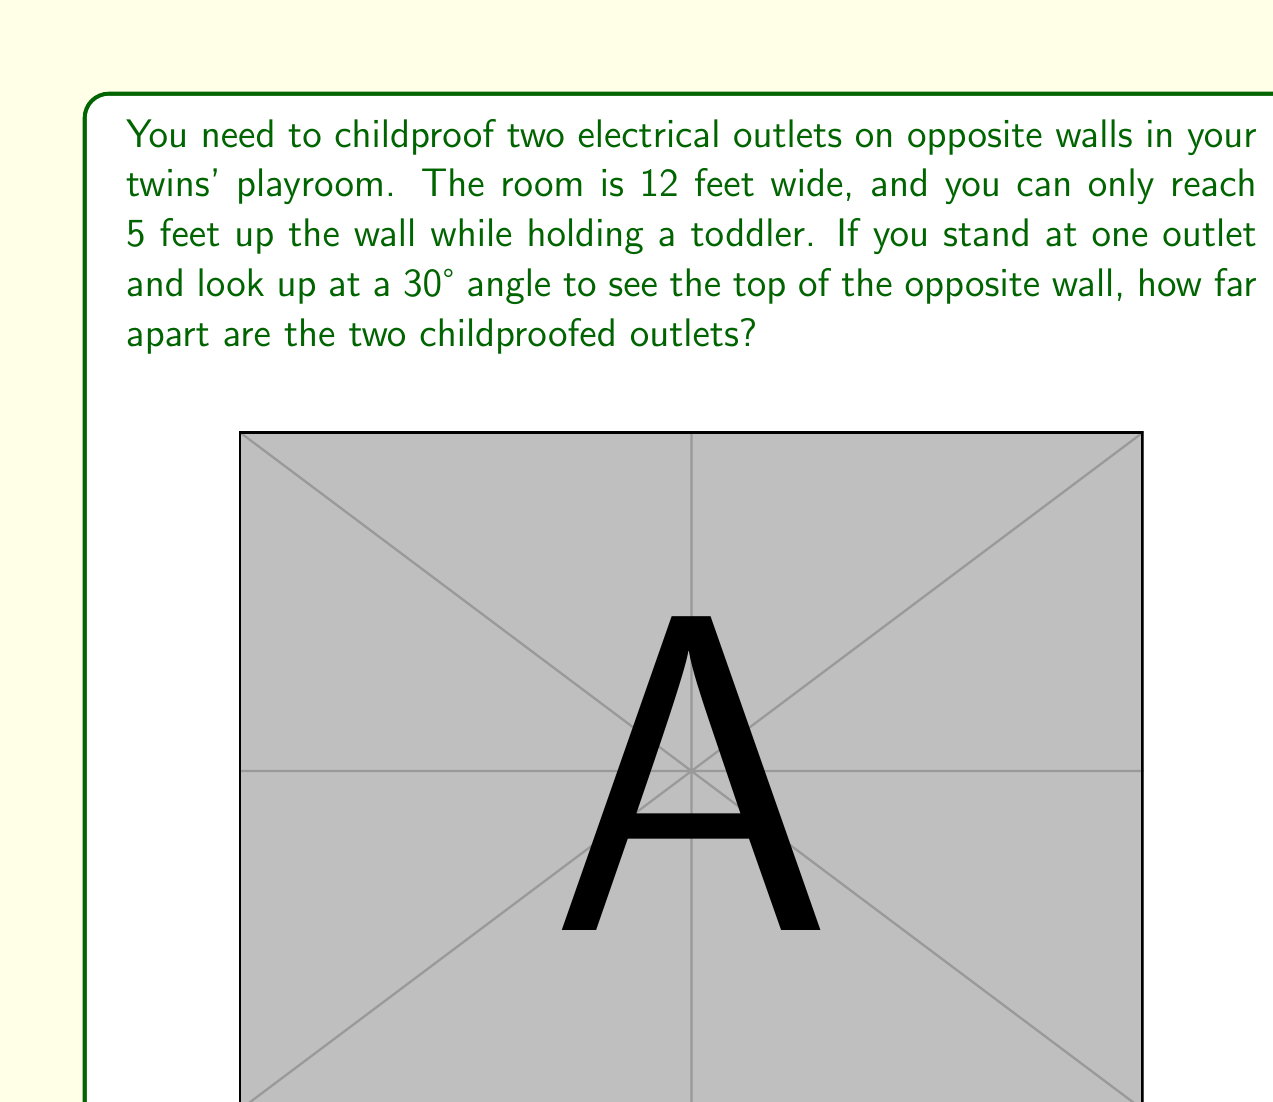Can you answer this question? Let's approach this step-by-step using trigonometry:

1) First, we need to find the height of the opposite wall. We can use the tangent function:

   $\tan(30°) = \frac{\text{opposite}}{\text{adjacent}} = \frac{\text{height} - 5}{12}$

2) We know that $\tan(30°) = \frac{1}{\sqrt{3}}$, so:

   $\frac{1}{\sqrt{3}} = \frac{\text{height} - 5}{12}$

3) Solving for height:
   
   $12 \cdot \frac{1}{\sqrt{3}} = \text{height} - 5$
   $\frac{12}{\sqrt{3}} + 5 = \text{height}$

4) Simplify:
   
   $\frac{12\sqrt{3}}{3} + 5 = \text{height}$
   $4\sqrt{3} + 5 \approx 11.93$ feet

5) Now we know the total height of the wall. The outlets are at 5 feet on each wall.

6) To find the distance between the outlets, we can use the Pythagorean theorem:

   $\text{distance}^2 = 12^2 + 5^2$

7) Solving:
   
   $\text{distance} = \sqrt{12^2 + 5^2} = \sqrt{144 + 25} = \sqrt{169}$

8) Simplify:
   
   $\text{distance} = 13$ feet
Answer: The two childproofed outlets are 13 feet apart. 